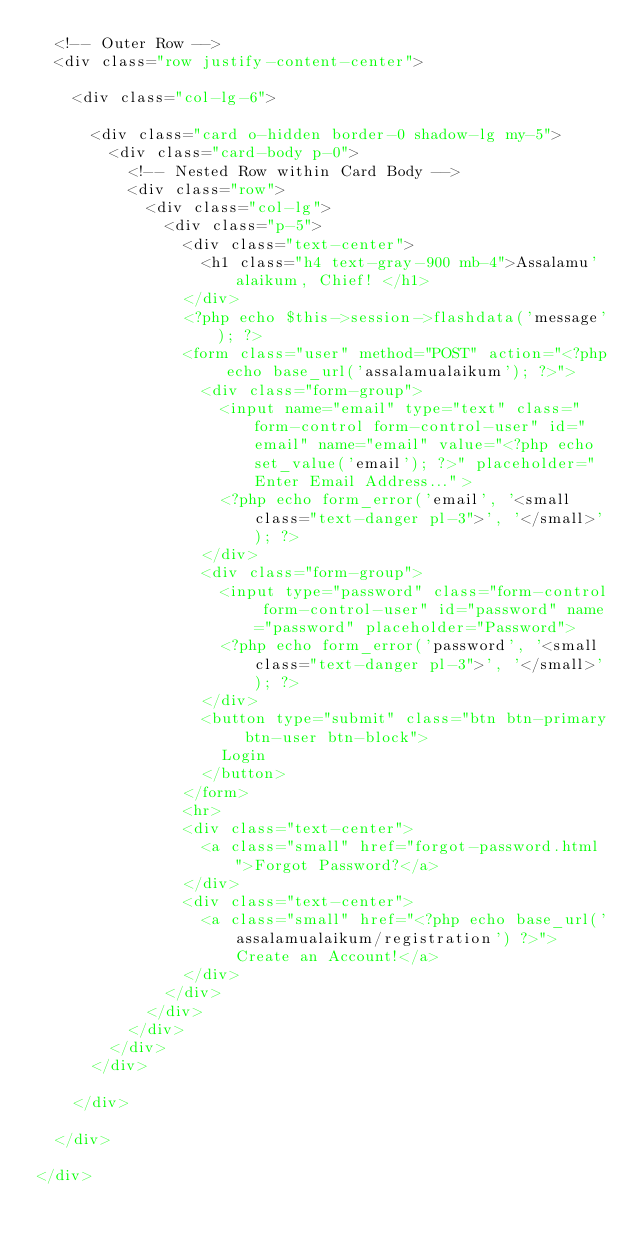<code> <loc_0><loc_0><loc_500><loc_500><_PHP_>	<!-- Outer Row -->
	<div class="row justify-content-center">

		<div class="col-lg-6">

			<div class="card o-hidden border-0 shadow-lg my-5">
				<div class="card-body p-0">
					<!-- Nested Row within Card Body -->
					<div class="row">
						<div class="col-lg">
							<div class="p-5">
								<div class="text-center">
									<h1 class="h4 text-gray-900 mb-4">Assalamu'alaikum, Chief! </h1>
								</div>
								<?php echo $this->session->flashdata('message'); ?>
								<form class="user" method="POST" action="<?php echo base_url('assalamualaikum'); ?>">
									<div class="form-group">
										<input name="email" type="text" class="form-control form-control-user" id="email" name="email" value="<?php echo set_value('email'); ?>" placeholder="Enter Email Address...">
										<?php echo form_error('email', '<small class="text-danger pl-3">', '</small>'); ?>
									</div>
									<div class="form-group">
										<input type="password" class="form-control form-control-user" id="password" name="password" placeholder="Password">
										<?php echo form_error('password', '<small class="text-danger pl-3">', '</small>'); ?>
									</div>
									<button type="submit" class="btn btn-primary btn-user btn-block">
										Login
									</button>
								</form>
								<hr>
								<div class="text-center">
									<a class="small" href="forgot-password.html">Forgot Password?</a>
								</div>
								<div class="text-center">
									<a class="small" href="<?php echo base_url('assalamualaikum/registration') ?>">Create an Account!</a>
								</div>
							</div>
						</div>
					</div>
				</div>
			</div>

		</div>

	</div>

</div></code> 